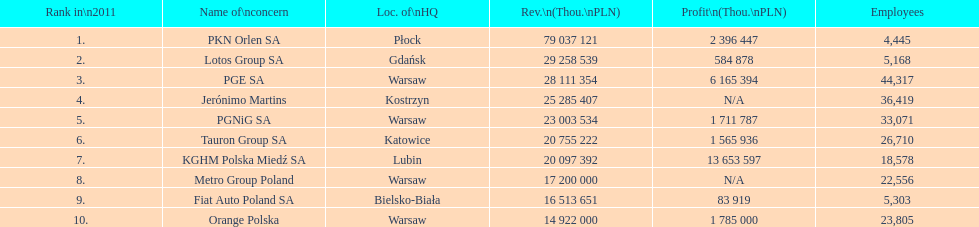Parse the full table. {'header': ['Rank in\\n2011', 'Name of\\nconcern', 'Loc. of\\nHQ', 'Rev.\\n(Thou.\\nPLN)', 'Profit\\n(Thou.\\nPLN)', 'Employees'], 'rows': [['1.', 'PKN Orlen SA', 'Płock', '79 037 121', '2 396 447', '4,445'], ['2.', 'Lotos Group SA', 'Gdańsk', '29 258 539', '584 878', '5,168'], ['3.', 'PGE SA', 'Warsaw', '28 111 354', '6 165 394', '44,317'], ['4.', 'Jerónimo Martins', 'Kostrzyn', '25 285 407', 'N/A', '36,419'], ['5.', 'PGNiG SA', 'Warsaw', '23 003 534', '1 711 787', '33,071'], ['6.', 'Tauron Group SA', 'Katowice', '20 755 222', '1 565 936', '26,710'], ['7.', 'KGHM Polska Miedź SA', 'Lubin', '20 097 392', '13 653 597', '18,578'], ['8.', 'Metro Group Poland', 'Warsaw', '17 200 000', 'N/A', '22,556'], ['9.', 'Fiat Auto Poland SA', 'Bielsko-Biała', '16 513 651', '83 919', '5,303'], ['10.', 'Orange Polska', 'Warsaw', '14 922 000', '1 785 000', '23,805']]} Which company had the most employees? PGE SA. 